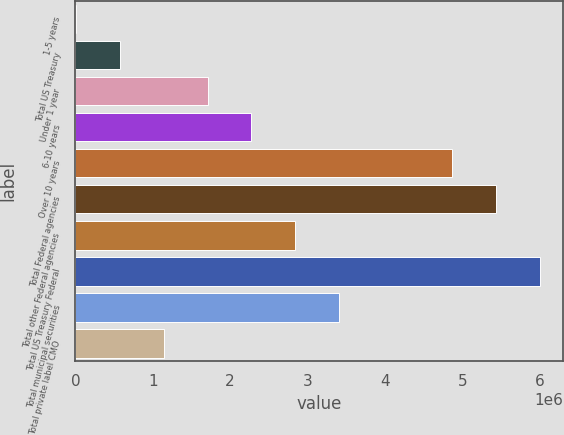<chart> <loc_0><loc_0><loc_500><loc_500><bar_chart><fcel>1-5 years<fcel>Total US Treasury<fcel>Under 1 year<fcel>6-10 years<fcel>Over 10 years<fcel>Total Federal agencies<fcel>Total other Federal agencies<fcel>Total US Treasury Federal<fcel>Total municipal securities<fcel>Total private label CMO<nl><fcel>5452<fcel>572876<fcel>1.70773e+06<fcel>2.27515e+06<fcel>4.8675e+06<fcel>5.43492e+06<fcel>2.84257e+06<fcel>6.00234e+06<fcel>3.41e+06<fcel>1.1403e+06<nl></chart> 